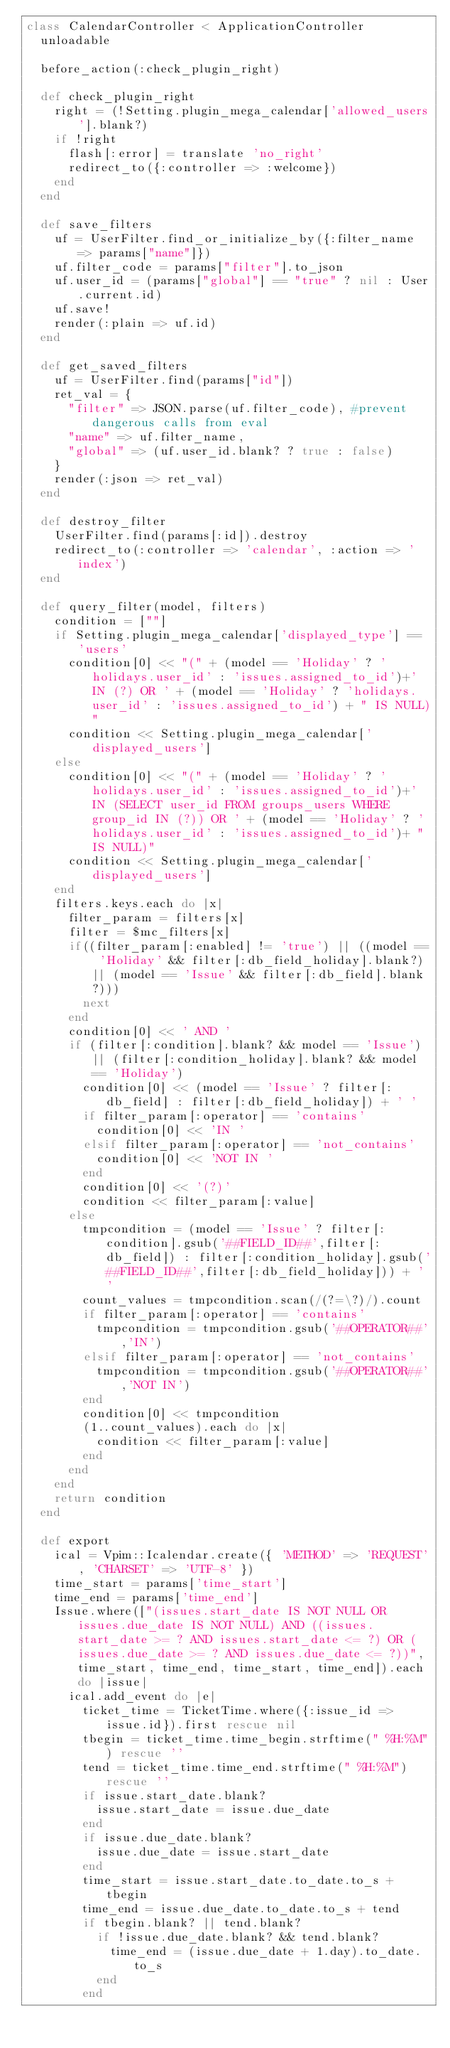<code> <loc_0><loc_0><loc_500><loc_500><_Ruby_>class CalendarController < ApplicationController
  unloadable

  before_action(:check_plugin_right)

  def check_plugin_right
    right = (!Setting.plugin_mega_calendar['allowed_users'].blank?)
    if !right
      flash[:error] = translate 'no_right'
      redirect_to({:controller => :welcome})
    end
  end

  def save_filters
    uf = UserFilter.find_or_initialize_by({:filter_name => params["name"]})
    uf.filter_code = params["filter"].to_json
    uf.user_id = (params["global"] == "true" ? nil : User.current.id)
    uf.save!
    render(:plain => uf.id)
  end

  def get_saved_filters
    uf = UserFilter.find(params["id"])
    ret_val = {
      "filter" => JSON.parse(uf.filter_code), #prevent dangerous calls from eval
      "name" => uf.filter_name,
      "global" => (uf.user_id.blank? ? true : false)
    }
    render(:json => ret_val)
  end

  def destroy_filter
    UserFilter.find(params[:id]).destroy
    redirect_to(:controller => 'calendar', :action => 'index')
  end

  def query_filter(model, filters)
    condition = [""]
    if Setting.plugin_mega_calendar['displayed_type'] == 'users'
      condition[0] << "(" + (model == 'Holiday' ? 'holidays.user_id' : 'issues.assigned_to_id')+' IN (?) OR ' + (model == 'Holiday' ? 'holidays.user_id' : 'issues.assigned_to_id') + " IS NULL)"
      condition << Setting.plugin_mega_calendar['displayed_users']
    else
      condition[0] << "(" + (model == 'Holiday' ? 'holidays.user_id' : 'issues.assigned_to_id')+' IN (SELECT user_id FROM groups_users WHERE group_id IN (?)) OR ' + (model == 'Holiday' ? 'holidays.user_id' : 'issues.assigned_to_id')+ " IS NULL)"
      condition << Setting.plugin_mega_calendar['displayed_users']
    end
    filters.keys.each do |x|
      filter_param = filters[x]
      filter = $mc_filters[x]
      if((filter_param[:enabled] != 'true') || ((model == 'Holiday' && filter[:db_field_holiday].blank?) || (model == 'Issue' && filter[:db_field].blank?)))
        next
      end
      condition[0] << ' AND '
      if (filter[:condition].blank? && model == 'Issue') || (filter[:condition_holiday].blank? && model == 'Holiday')
        condition[0] << (model == 'Issue' ? filter[:db_field] : filter[:db_field_holiday]) + ' '
        if filter_param[:operator] == 'contains'
          condition[0] << 'IN '
        elsif filter_param[:operator] == 'not_contains'
          condition[0] << 'NOT IN '
        end
        condition[0] << '(?)'
        condition << filter_param[:value]
      else
        tmpcondition = (model == 'Issue' ? filter[:condition].gsub('##FIELD_ID##',filter[:db_field]) : filter[:condition_holiday].gsub('##FIELD_ID##',filter[:db_field_holiday])) + ' '
        count_values = tmpcondition.scan(/(?=\?)/).count
        if filter_param[:operator] == 'contains'
          tmpcondition = tmpcondition.gsub('##OPERATOR##','IN')
        elsif filter_param[:operator] == 'not_contains'
          tmpcondition = tmpcondition.gsub('##OPERATOR##','NOT IN')
        end
        condition[0] << tmpcondition
        (1..count_values).each do |x|
          condition << filter_param[:value]
        end
      end
    end
    return condition
  end

  def export
    ical = Vpim::Icalendar.create({ 'METHOD' => 'REQUEST', 'CHARSET' => 'UTF-8' })
    time_start = params['time_start']
    time_end = params['time_end']
    Issue.where(["(issues.start_date IS NOT NULL OR issues.due_date IS NOT NULL) AND ((issues.start_date >= ? AND issues.start_date <= ?) OR (issues.due_date >= ? AND issues.due_date <= ?))", time_start, time_end, time_start, time_end]).each do |issue|
      ical.add_event do |e|
        ticket_time = TicketTime.where({:issue_id => issue.id}).first rescue nil
        tbegin = ticket_time.time_begin.strftime(" %H:%M") rescue ''
        tend = ticket_time.time_end.strftime(" %H:%M") rescue ''
        if issue.start_date.blank?
          issue.start_date = issue.due_date
        end
        if issue.due_date.blank?
          issue.due_date = issue.start_date
        end
        time_start = issue.start_date.to_date.to_s + tbegin
        time_end = issue.due_date.to_date.to_s + tend
        if tbegin.blank? || tend.blank?
          if !issue.due_date.blank? && tend.blank?
            time_end = (issue.due_date + 1.day).to_date.to_s
          end
        end</code> 